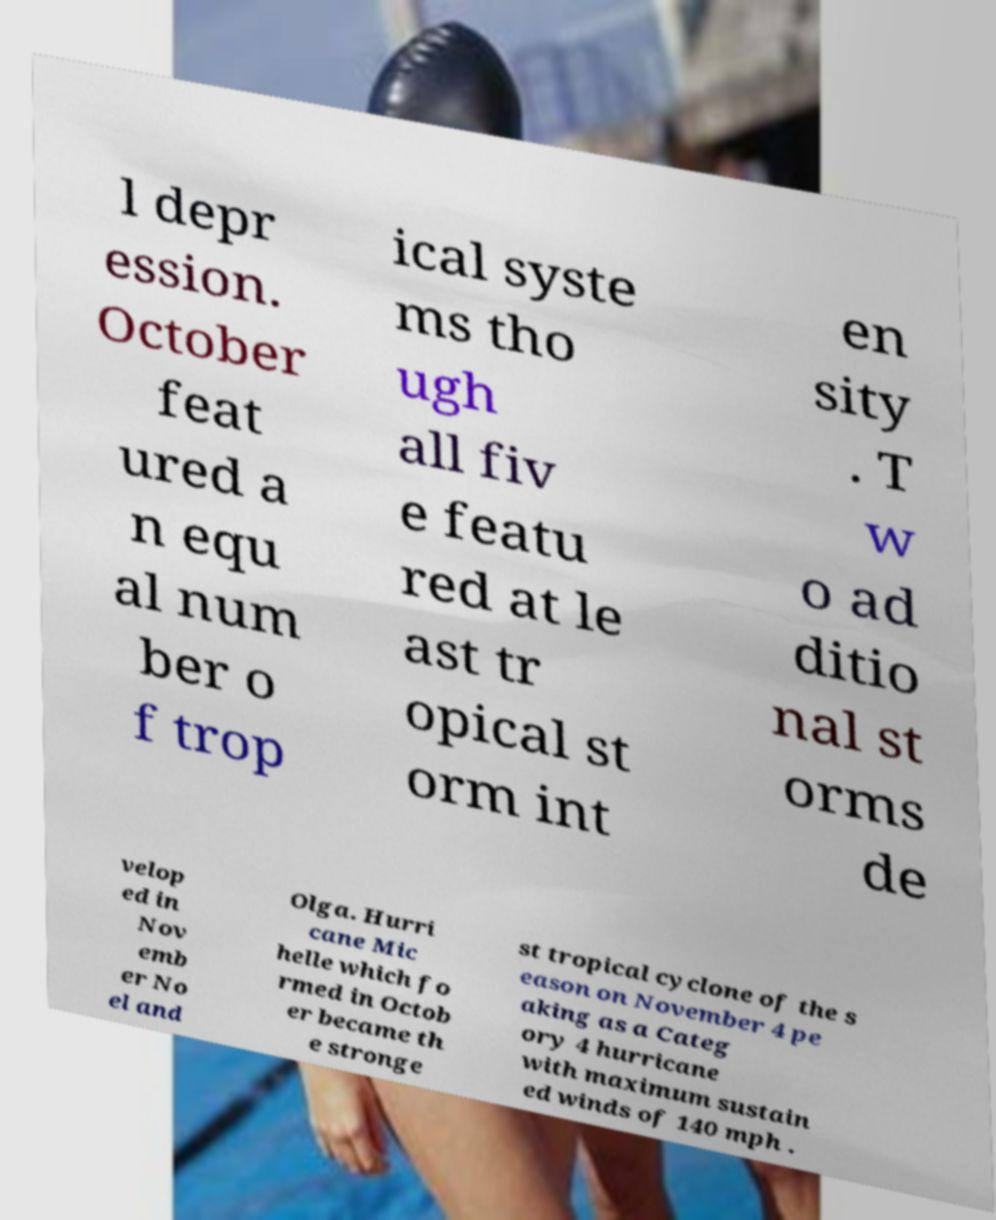Can you accurately transcribe the text from the provided image for me? l depr ession. October feat ured a n equ al num ber o f trop ical syste ms tho ugh all fiv e featu red at le ast tr opical st orm int en sity . T w o ad ditio nal st orms de velop ed in Nov emb er No el and Olga. Hurri cane Mic helle which fo rmed in Octob er became th e stronge st tropical cyclone of the s eason on November 4 pe aking as a Categ ory 4 hurricane with maximum sustain ed winds of 140 mph . 